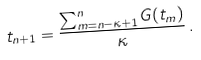Convert formula to latex. <formula><loc_0><loc_0><loc_500><loc_500>t _ { n + 1 } = \frac { \sum _ { m = n - \kappa + 1 } ^ { n } G ( t _ { m } ) } { \kappa } \, .</formula> 